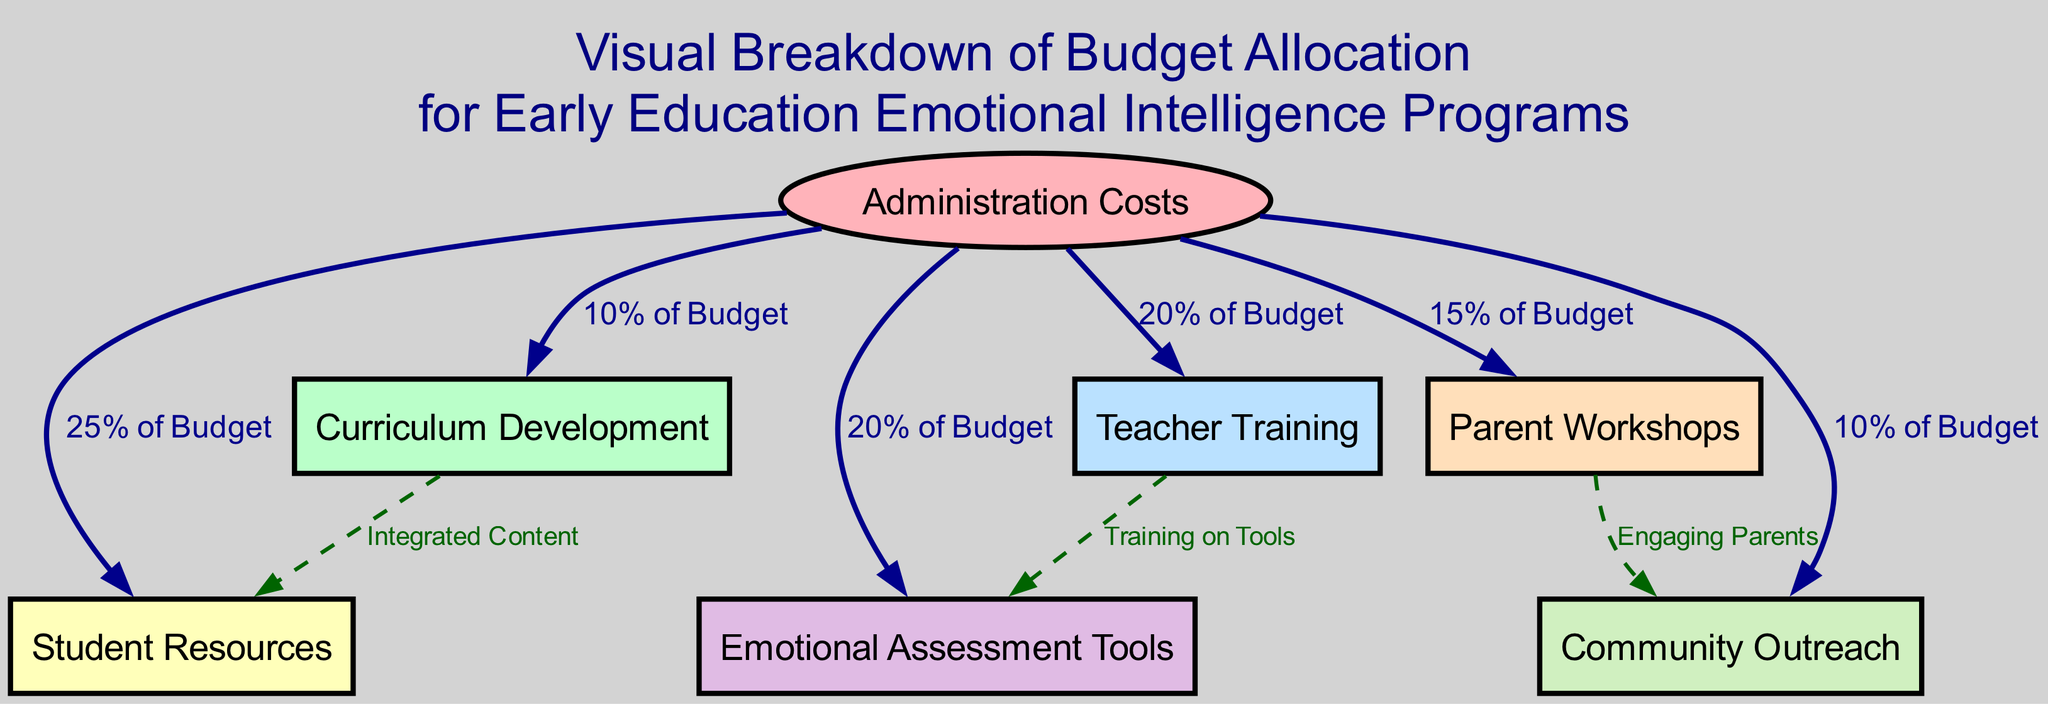What is the total number of nodes in the budget allocation diagram? The diagram contains a total of 7 nodes, representing different aspects of budget allocation. This can be counted directly from the list of nodes provided in the data.
Answer: 7 What percentage of the budget is allocated to student resources? The diagram shows that 25% of the budget is allocated to student resources, indicated by the edge connected to administration costs labeled "25% of Budget."
Answer: 25% Which component is allocated the highest percentage of the budget? By analyzing the edges from administration costs, teacher training is allocated 20% of the budget, but student resources has the highest allocation at 25% among all components, leading to that conclusion.
Answer: Student Resources What is the relationship between curriculum development and student resources? The edge from curriculum development to student resources indicates integrated content, showing that curriculum development directly feeds into student resources. The edge is also labeled accordingly as "Integrated Content."
Answer: Integrated Content How many connections are there from administration costs? There are 6 edges stemming from administration costs, as evidenced by the individual connections to curriculum development, teacher training, student resources, parent workshops, emotional assessment tools, and community outreach, which can be counted.
Answer: 6 What training-related connection exists between teacher training and emotional assessment tools? The edge between teacher training and emotional assessment tools is labeled "Training on Tools," denoting that there is a specific training connection focused on the tools necessary for emotional assessments.
Answer: Training on Tools What is the purpose of parent workshops as indicated in the diagram? The connection between parent workshops and community outreach is labeled "Engaging Parents," showing that the purpose of parent workshops is to involve parents in community outreach efforts, as clearly denoted by that edge.
Answer: Engaging Parents Which component has no direct outgoing relationships in the diagram? The relationship analysis reveals that "Curriculum Development" does not have any outgoing edges to other components except for the one leading to "Student Resources," indicating its primary role in integrated content without additional outputs.
Answer: Curriculum Development 